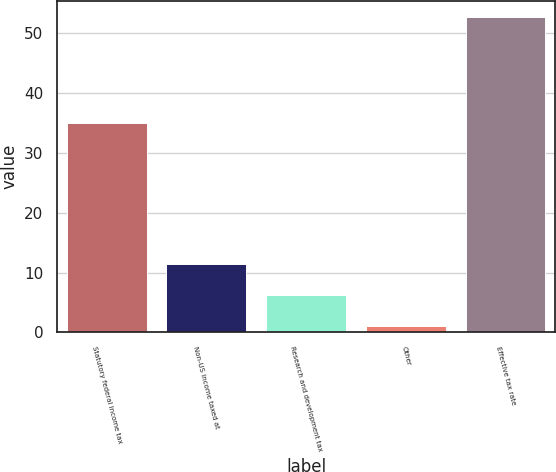<chart> <loc_0><loc_0><loc_500><loc_500><bar_chart><fcel>Statutory federal income tax<fcel>Non-US income taxed at<fcel>Research and development tax<fcel>Other<fcel>Effective tax rate<nl><fcel>35<fcel>11.44<fcel>6.27<fcel>1.1<fcel>52.8<nl></chart> 